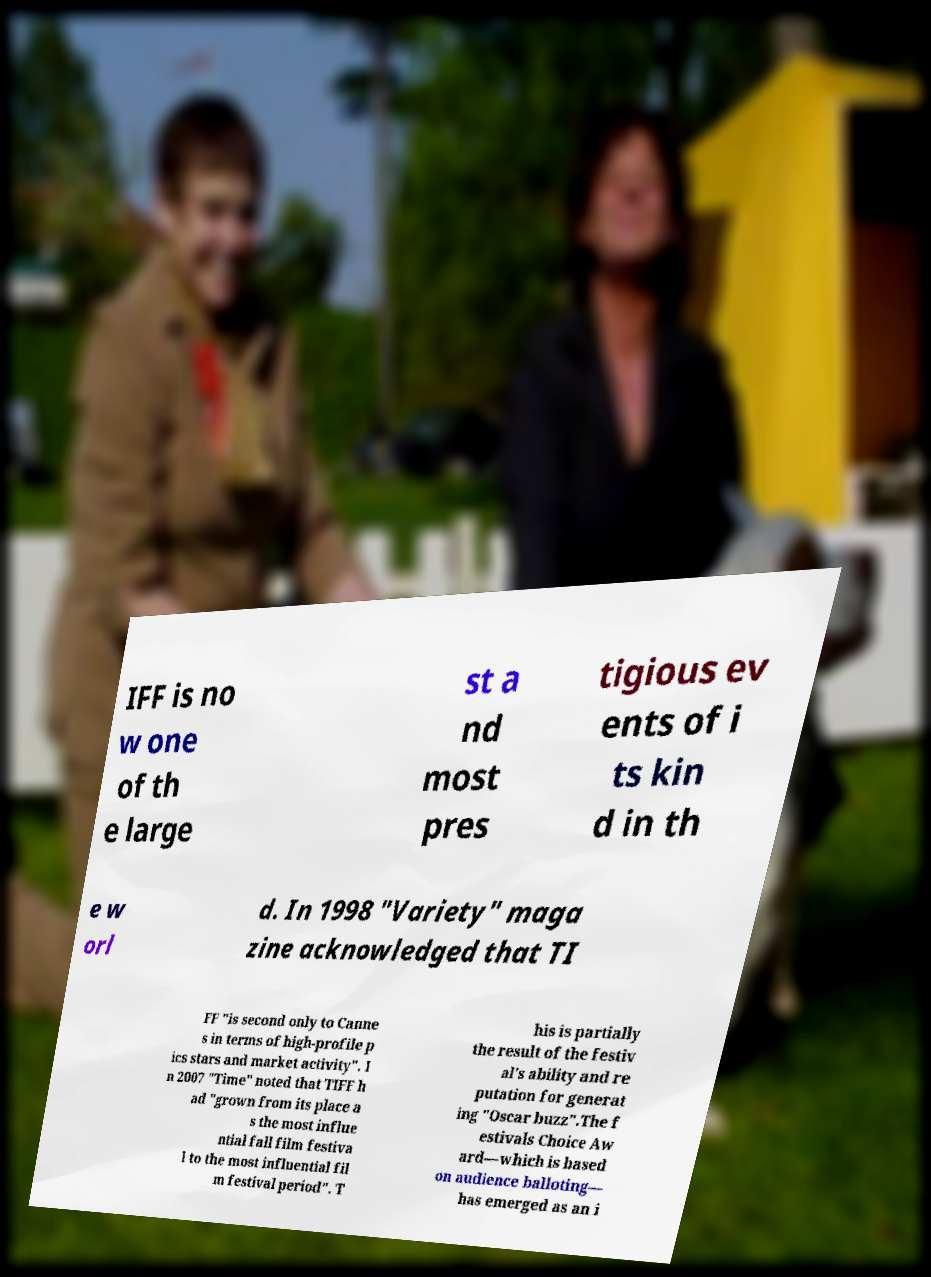Could you assist in decoding the text presented in this image and type it out clearly? IFF is no w one of th e large st a nd most pres tigious ev ents of i ts kin d in th e w orl d. In 1998 "Variety" maga zine acknowledged that TI FF "is second only to Canne s in terms of high-profile p ics stars and market activity". I n 2007 "Time" noted that TIFF h ad "grown from its place a s the most influe ntial fall film festiva l to the most influential fil m festival period". T his is partially the result of the festiv al's ability and re putation for generat ing "Oscar buzz".The f estivals Choice Aw ard—which is based on audience balloting— has emerged as an i 